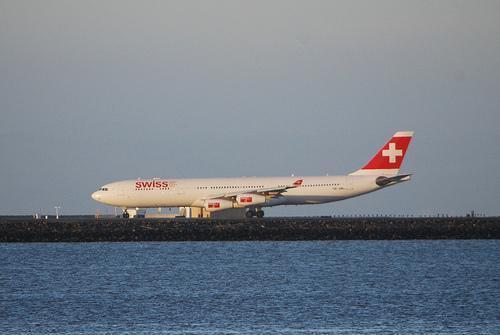How many planes are there?
Give a very brief answer. 1. 